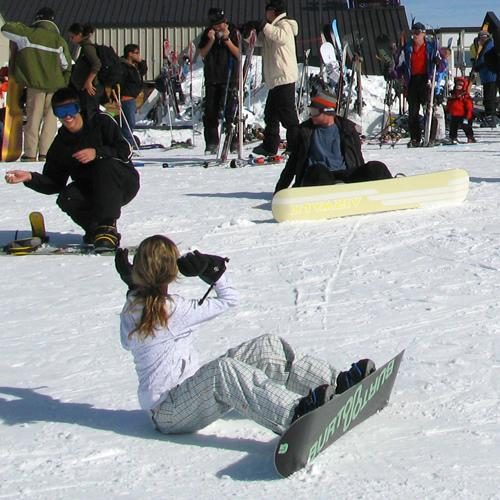What are the people sitting in the snow doing? talking 